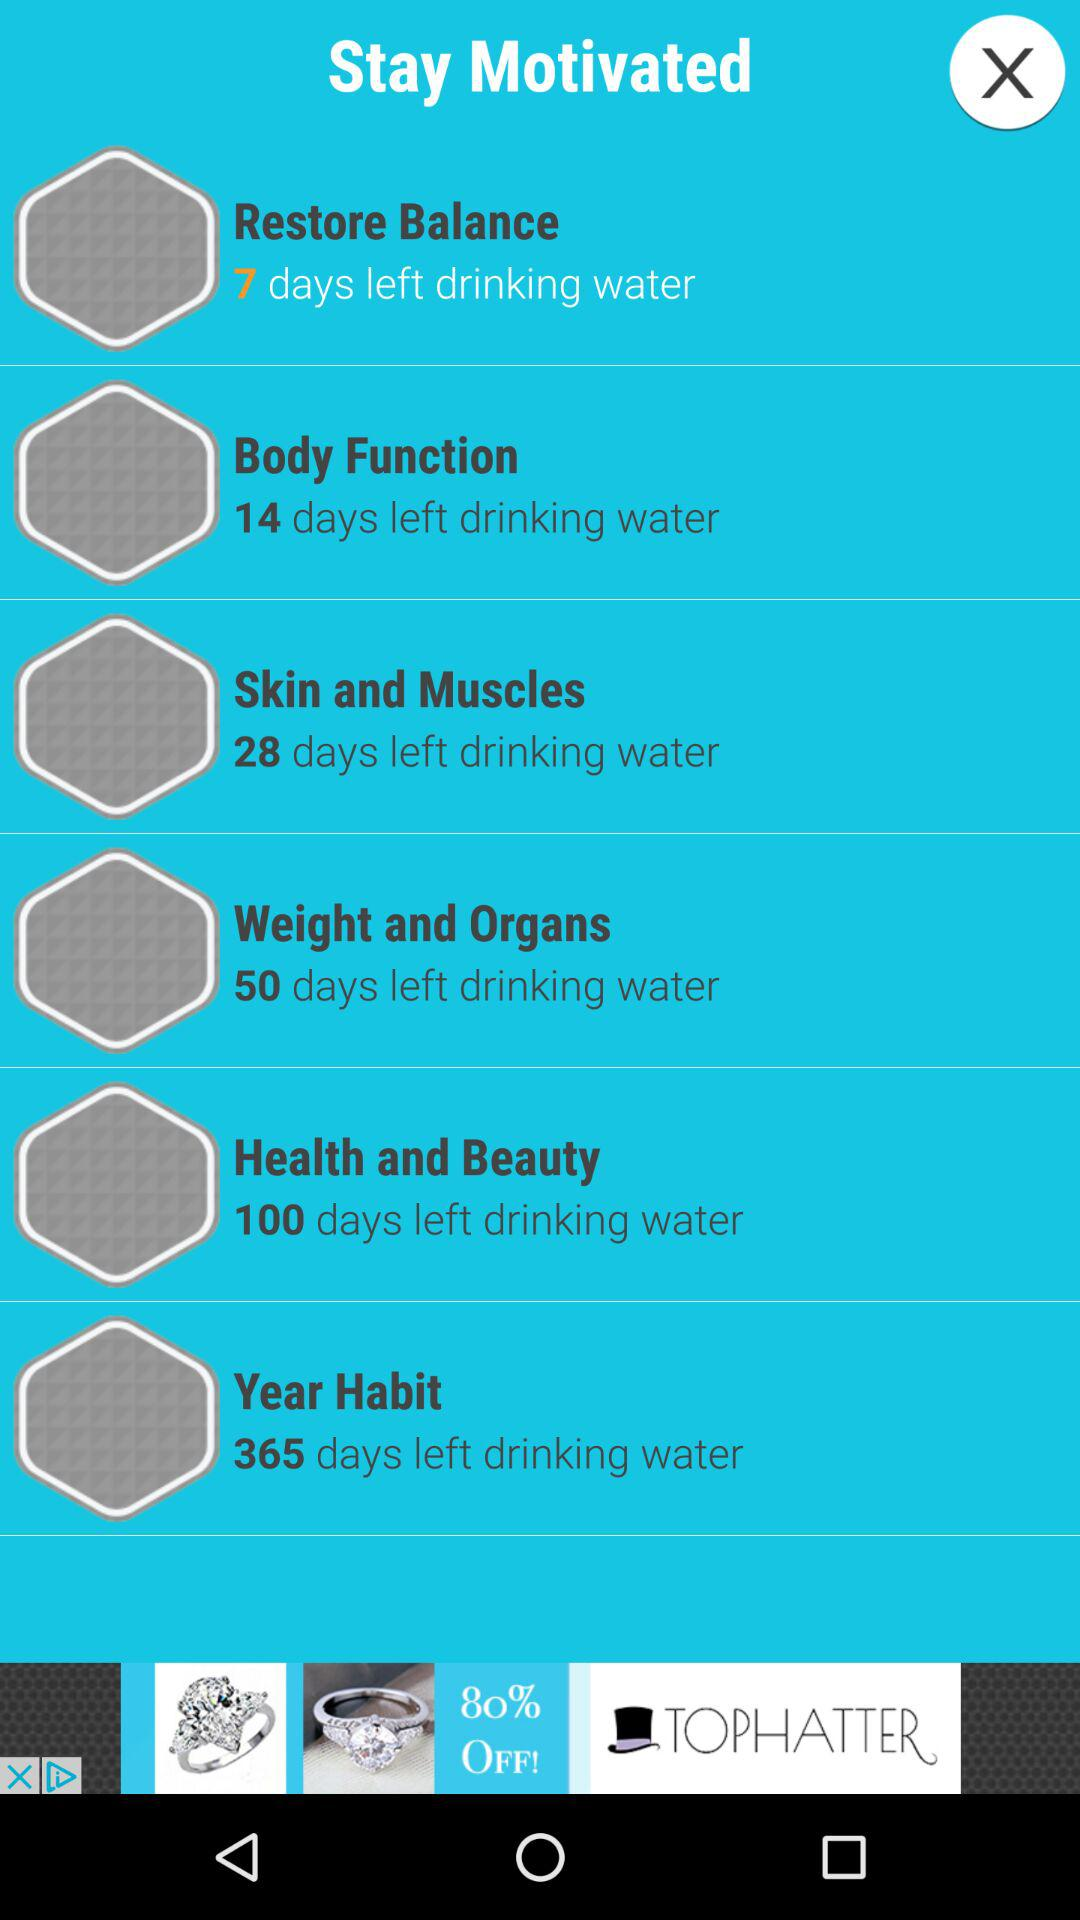How many days are left in the "Skin and Muscles"? There are 28 days left in the "Skin and Muscles". 